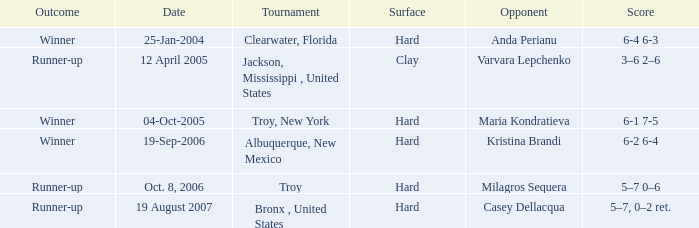What was the playing surface of the game that ended with a score of 6-1, 7-5? Hard. 